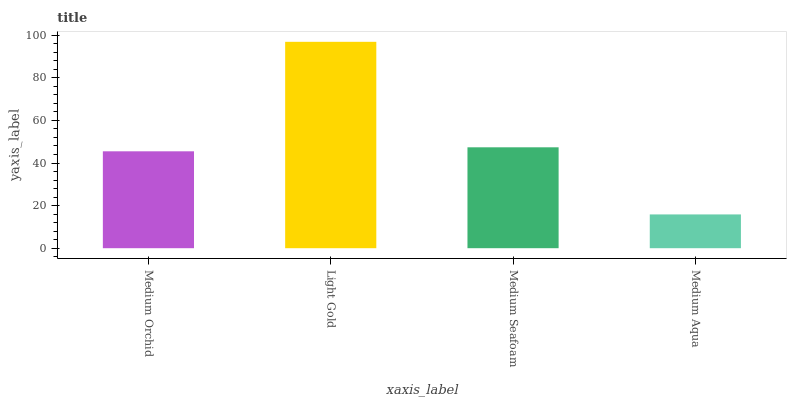Is Medium Aqua the minimum?
Answer yes or no. Yes. Is Light Gold the maximum?
Answer yes or no. Yes. Is Medium Seafoam the minimum?
Answer yes or no. No. Is Medium Seafoam the maximum?
Answer yes or no. No. Is Light Gold greater than Medium Seafoam?
Answer yes or no. Yes. Is Medium Seafoam less than Light Gold?
Answer yes or no. Yes. Is Medium Seafoam greater than Light Gold?
Answer yes or no. No. Is Light Gold less than Medium Seafoam?
Answer yes or no. No. Is Medium Seafoam the high median?
Answer yes or no. Yes. Is Medium Orchid the low median?
Answer yes or no. Yes. Is Medium Orchid the high median?
Answer yes or no. No. Is Medium Aqua the low median?
Answer yes or no. No. 